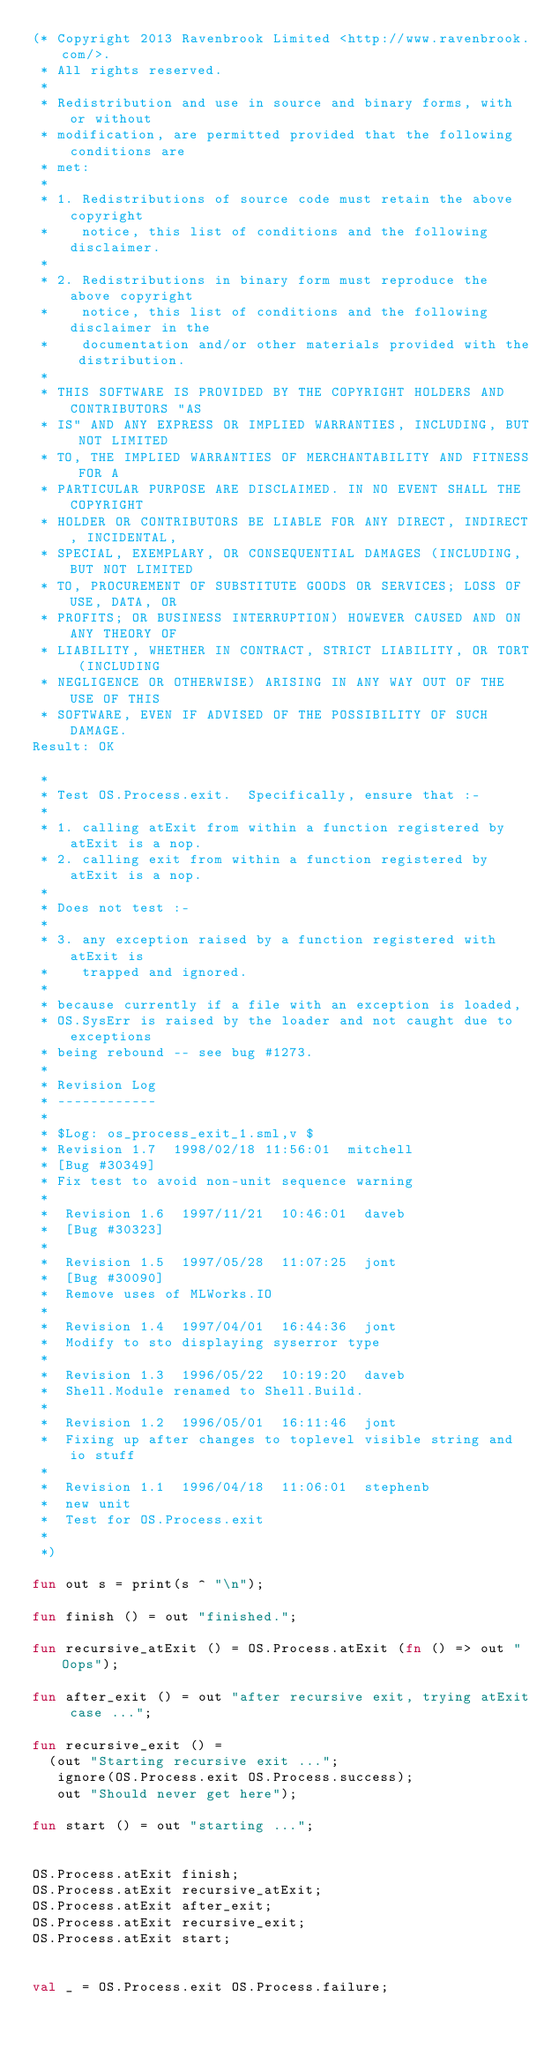<code> <loc_0><loc_0><loc_500><loc_500><_SML_>(* Copyright 2013 Ravenbrook Limited <http://www.ravenbrook.com/>.
 * All rights reserved.
 * 
 * Redistribution and use in source and binary forms, with or without
 * modification, are permitted provided that the following conditions are
 * met:
 * 
 * 1. Redistributions of source code must retain the above copyright
 *    notice, this list of conditions and the following disclaimer.
 * 
 * 2. Redistributions in binary form must reproduce the above copyright
 *    notice, this list of conditions and the following disclaimer in the
 *    documentation and/or other materials provided with the distribution.
 * 
 * THIS SOFTWARE IS PROVIDED BY THE COPYRIGHT HOLDERS AND CONTRIBUTORS "AS
 * IS" AND ANY EXPRESS OR IMPLIED WARRANTIES, INCLUDING, BUT NOT LIMITED
 * TO, THE IMPLIED WARRANTIES OF MERCHANTABILITY AND FITNESS FOR A
 * PARTICULAR PURPOSE ARE DISCLAIMED. IN NO EVENT SHALL THE COPYRIGHT
 * HOLDER OR CONTRIBUTORS BE LIABLE FOR ANY DIRECT, INDIRECT, INCIDENTAL,
 * SPECIAL, EXEMPLARY, OR CONSEQUENTIAL DAMAGES (INCLUDING, BUT NOT LIMITED
 * TO, PROCUREMENT OF SUBSTITUTE GOODS OR SERVICES; LOSS OF USE, DATA, OR
 * PROFITS; OR BUSINESS INTERRUPTION) HOWEVER CAUSED AND ON ANY THEORY OF
 * LIABILITY, WHETHER IN CONTRACT, STRICT LIABILITY, OR TORT (INCLUDING
 * NEGLIGENCE OR OTHERWISE) ARISING IN ANY WAY OUT OF THE USE OF THIS
 * SOFTWARE, EVEN IF ADVISED OF THE POSSIBILITY OF SUCH DAMAGE.
Result: OK

 *
 * Test OS.Process.exit.  Specifically, ensure that :-
 *
 * 1. calling atExit from within a function registered by atExit is a nop.
 * 2. calling exit from within a function registered by atExit is a nop.
 *
 * Does not test :-
 *
 * 3. any exception raised by a function registered with atExit is 
 *    trapped and ignored.
 *
 * because currently if a file with an exception is loaded, 
 * OS.SysErr is raised by the loader and not caught due to exceptions
 * being rebound -- see bug #1273.
 * 
 * Revision Log
 * ------------
 *
 * $Log: os_process_exit_1.sml,v $
 * Revision 1.7  1998/02/18 11:56:01  mitchell
 * [Bug #30349]
 * Fix test to avoid non-unit sequence warning
 *
 *  Revision 1.6  1997/11/21  10:46:01  daveb
 *  [Bug #30323]
 *
 *  Revision 1.5  1997/05/28  11:07:25  jont
 *  [Bug #30090]
 *  Remove uses of MLWorks.IO
 *
 *  Revision 1.4  1997/04/01  16:44:36  jont
 *  Modify to sto displaying syserror type
 *
 *  Revision 1.3  1996/05/22  10:19:20  daveb
 *  Shell.Module renamed to Shell.Build.
 *
 *  Revision 1.2  1996/05/01  16:11:46  jont
 *  Fixing up after changes to toplevel visible string and io stuff
 *
 *  Revision 1.1  1996/04/18  11:06:01  stephenb
 *  new unit
 *  Test for OS.Process.exit
 *
 *)

fun out s = print(s ^ "\n");

fun finish () = out "finished.";

fun recursive_atExit () = OS.Process.atExit (fn () => out "Oops");

fun after_exit () = out "after recursive exit, trying atExit case ...";

fun recursive_exit () = 
  (out "Starting recursive exit ...";
   ignore(OS.Process.exit OS.Process.success);
   out "Should never get here");

fun start () = out "starting ...";


OS.Process.atExit finish;
OS.Process.atExit recursive_atExit;
OS.Process.atExit after_exit;
OS.Process.atExit recursive_exit;
OS.Process.atExit start;


val _ = OS.Process.exit OS.Process.failure;
</code> 